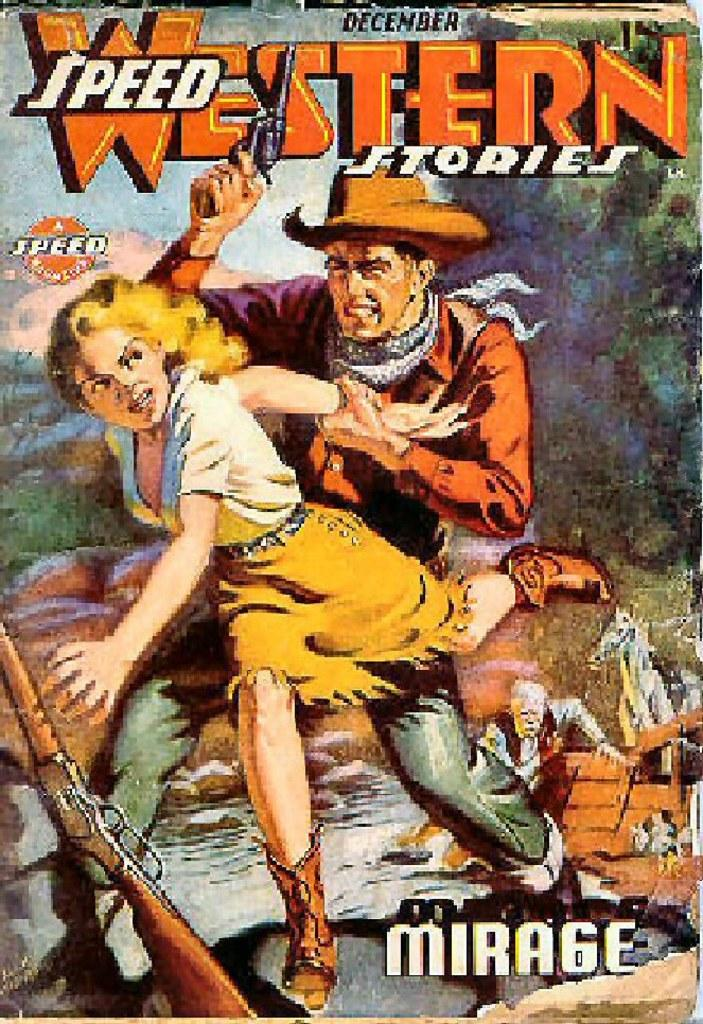<image>
Create a compact narrative representing the image presented. December Western Speed Stories book cover from Mirage. 